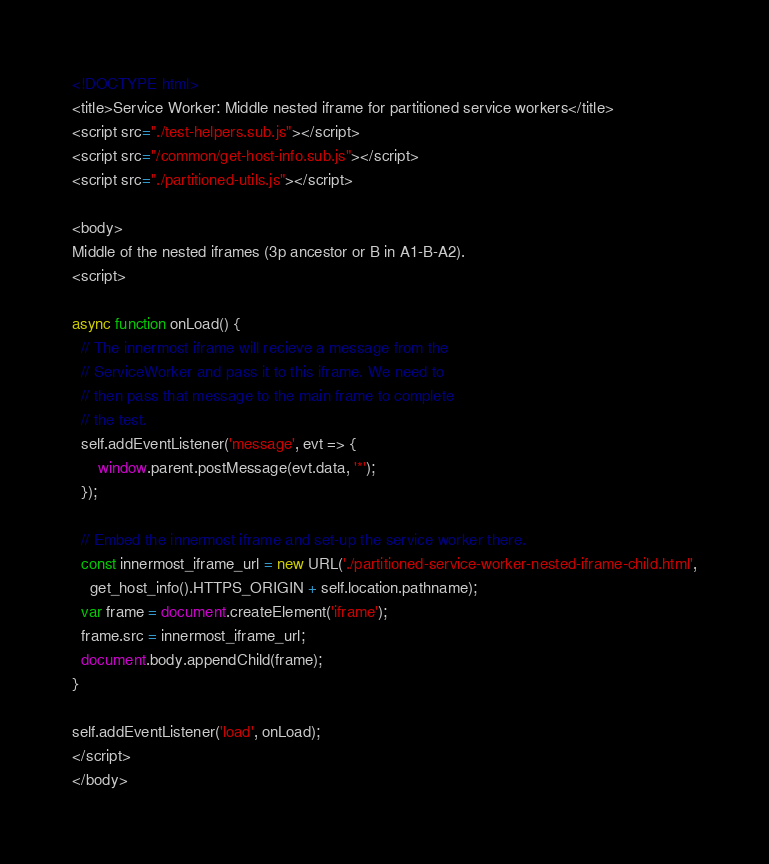Convert code to text. <code><loc_0><loc_0><loc_500><loc_500><_HTML_><!DOCTYPE html>
<title>Service Worker: Middle nested iframe for partitioned service workers</title>
<script src="./test-helpers.sub.js"></script>
<script src="/common/get-host-info.sub.js"></script>
<script src="./partitioned-utils.js"></script>

<body>
Middle of the nested iframes (3p ancestor or B in A1-B-A2).
<script>

async function onLoad() {
  // The innermost iframe will recieve a message from the
  // ServiceWorker and pass it to this iframe. We need to
  // then pass that message to the main frame to complete
  // the test.
  self.addEventListener('message', evt => {
      window.parent.postMessage(evt.data, '*');
  });

  // Embed the innermost iframe and set-up the service worker there.
  const innermost_iframe_url = new URL('./partitioned-service-worker-nested-iframe-child.html',
    get_host_info().HTTPS_ORIGIN + self.location.pathname);
  var frame = document.createElement('iframe');
  frame.src = innermost_iframe_url;
  document.body.appendChild(frame);
}

self.addEventListener('load', onLoad);
</script>
</body></code> 